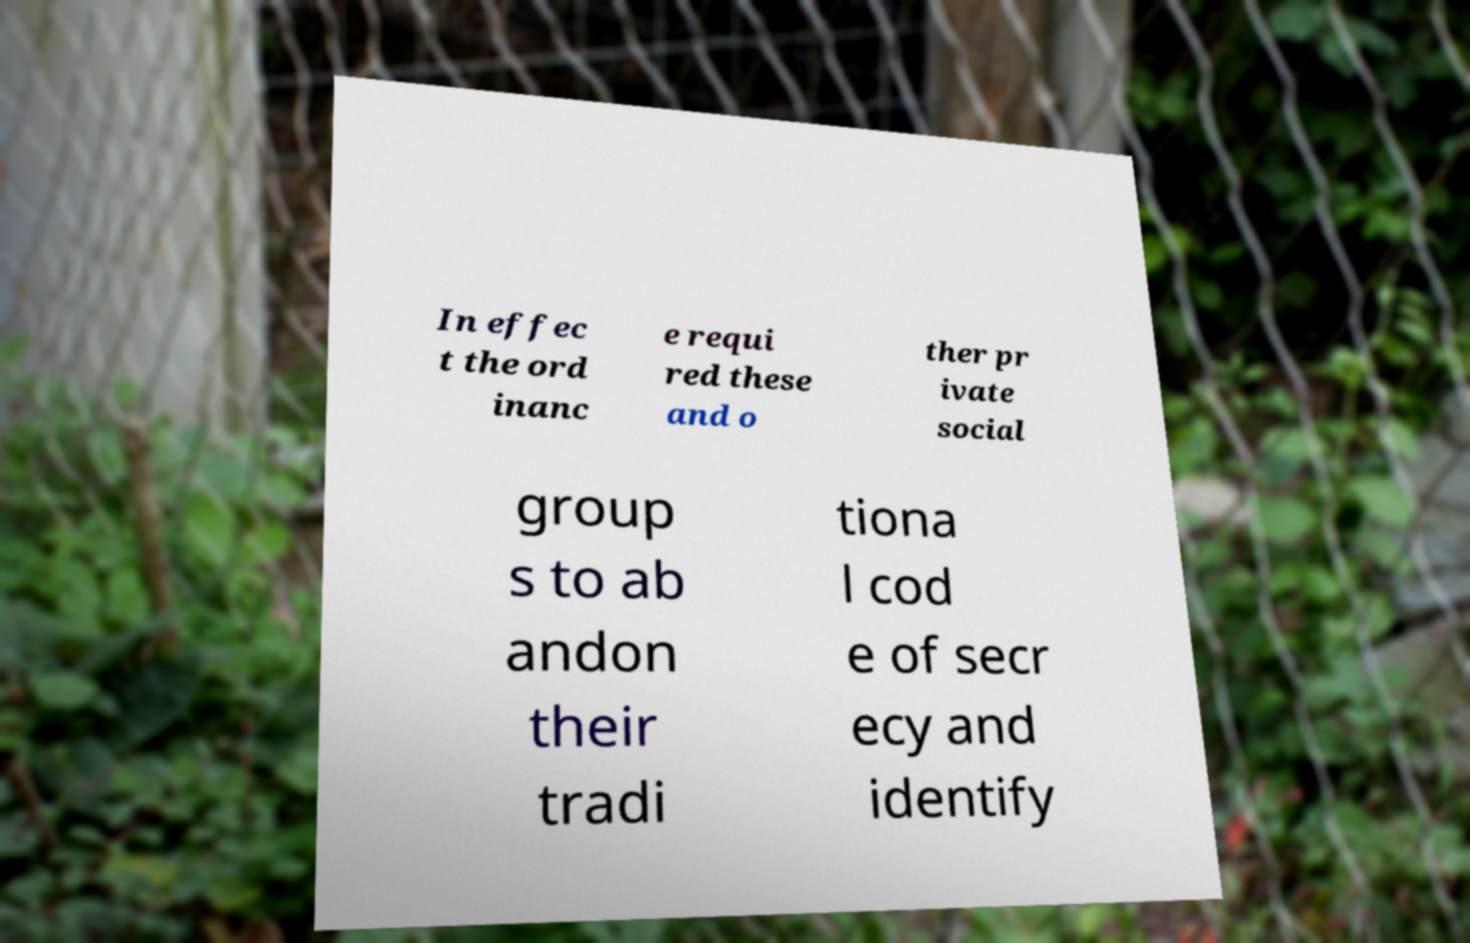For documentation purposes, I need the text within this image transcribed. Could you provide that? In effec t the ord inanc e requi red these and o ther pr ivate social group s to ab andon their tradi tiona l cod e of secr ecy and identify 